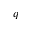Convert formula to latex. <formula><loc_0><loc_0><loc_500><loc_500>q</formula> 